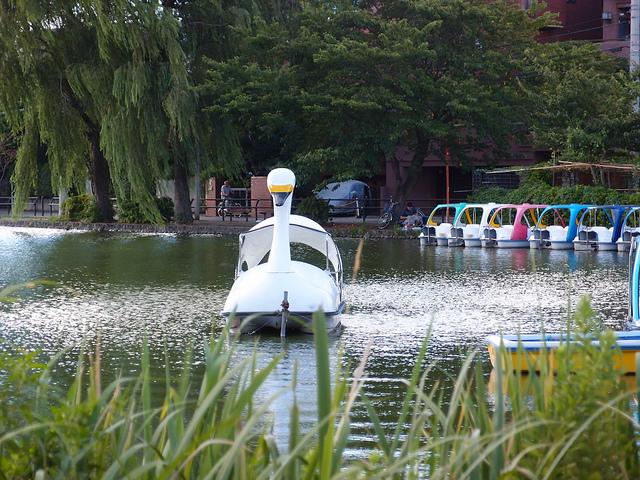How many boats are in the water?
Be succinct. 8. Is this photo taken in the ocean?
Quick response, please. No. Is this boat shaped like a swan?
Short answer required. Yes. 